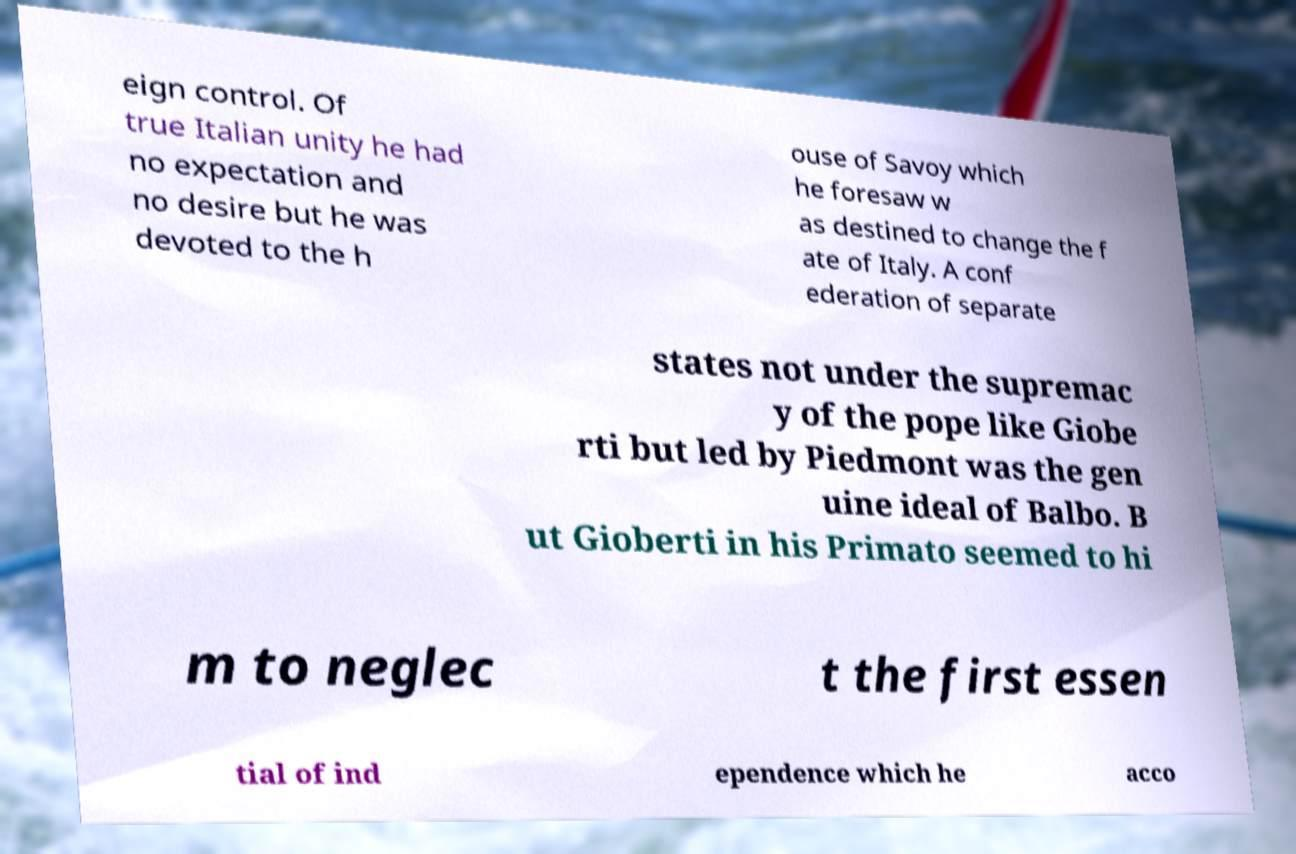Could you extract and type out the text from this image? eign control. Of true Italian unity he had no expectation and no desire but he was devoted to the h ouse of Savoy which he foresaw w as destined to change the f ate of Italy. A conf ederation of separate states not under the supremac y of the pope like Giobe rti but led by Piedmont was the gen uine ideal of Balbo. B ut Gioberti in his Primato seemed to hi m to neglec t the first essen tial of ind ependence which he acco 